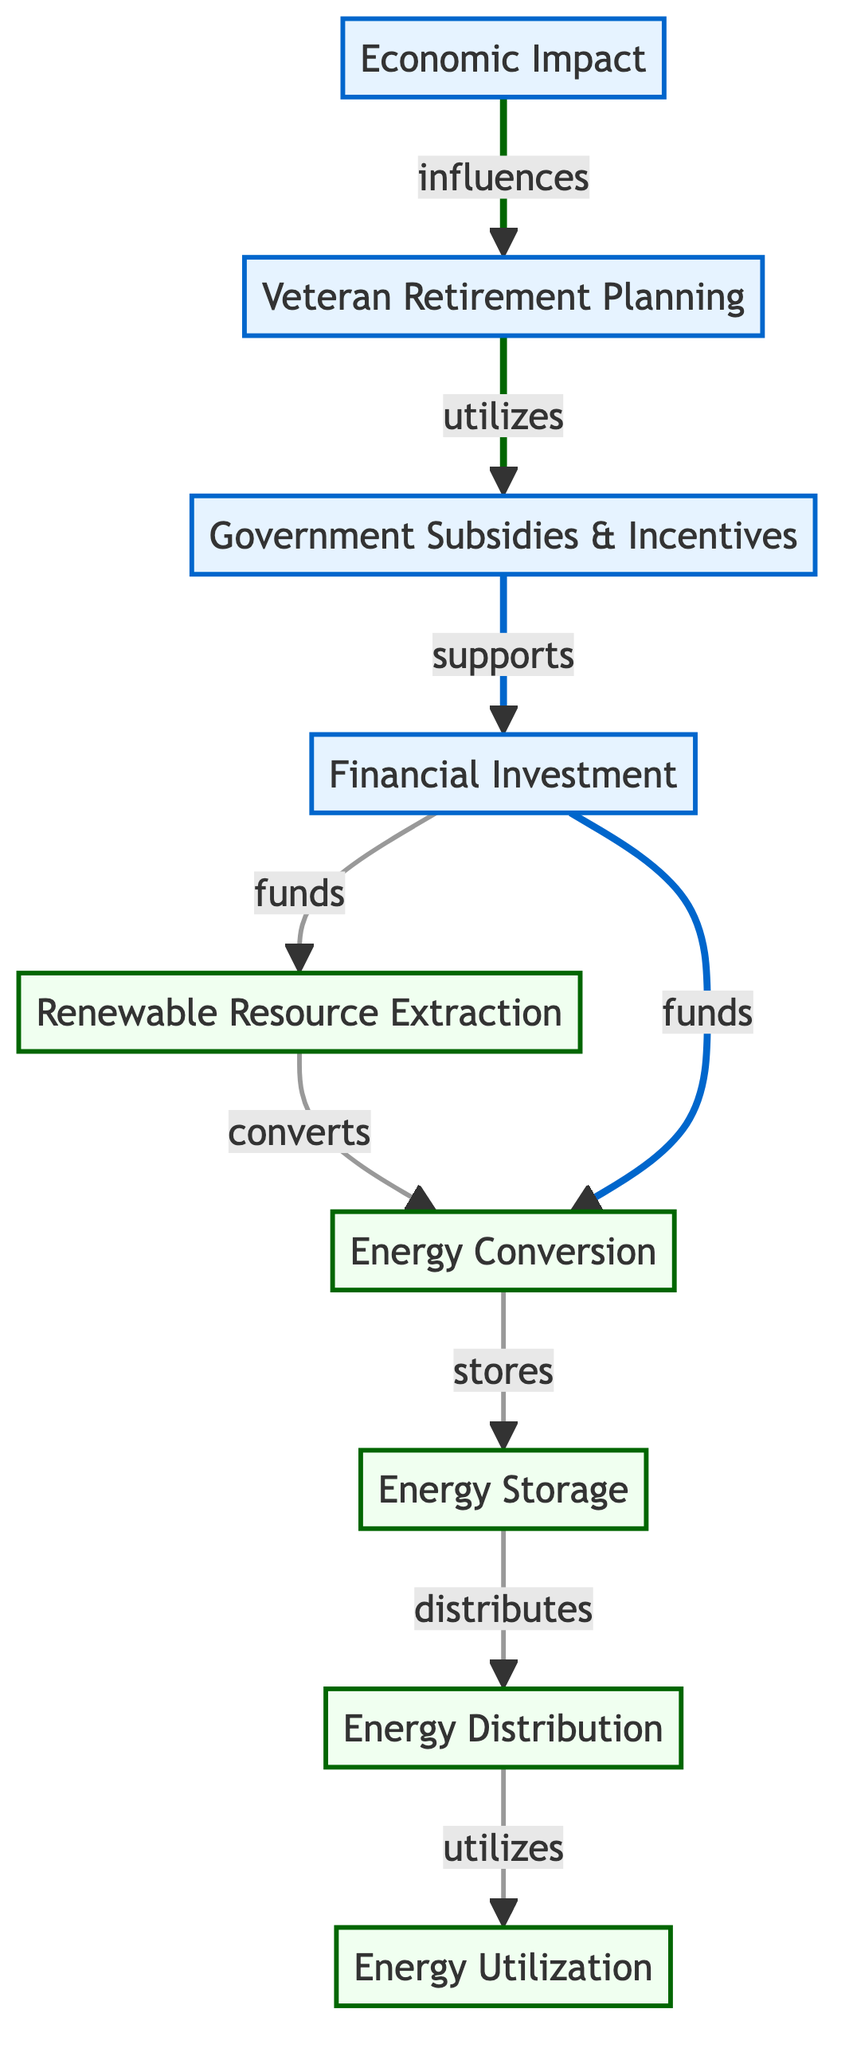What is the first step in the renewable energy lifecycle? The diagram indicates that the first step is "Renewable Resource Extraction." This is the initial node from which the entire process flows.
Answer: Renewable Resource Extraction Which nodes are classified as energy-related? The nodes classified as energy-related are "Renewable Resource Extraction," "Energy Conversion," "Energy Storage," "Energy Distribution," and "Energy Utilization." These are marked under the class 'energy' in the diagram.
Answer: Five nodes What financial element funds the energy lifecycle? The diagram shows that "Financial Investment" is the element that funds various stages of the energy lifecycle, including both extraction and conversion processes.
Answer: Financial Investment How do government subsidies influence financial investment? According to the diagram, "Government Subsidies & Incentives" support "Financial Investment," indicating that these subsidies provide necessary funds for investments in renewable energy.
Answer: Support What is utilized in the veteran retirement planning process? The diagram illustrates that "Government Subsidies & Incentives" are utilized within the "Veteran Retirement Planning," suggesting that veterans can benefit from these incentives in their financial planning.
Answer: Government Subsidies & Incentives How many interactions lead from financial investment to energy extraction? The diagram shows one direct interaction where "Financial Investment" funds "Renewable Resource Extraction." Therefore, there is only one interaction in this case.
Answer: One interaction What is the relationship between economic impact and veteran retirement planning? The diagram states that "Economic Impact" influences "Veteran Retirement Planning," which indicates that economic conditions can affect the financial strategies of veterans.
Answer: Influences What is the final stage of the energy lifecycle shown in the diagram? The last node in the flow of the diagram is "Energy Utilization," which represents the final application of renewable energy.
Answer: Energy Utilization How many total nodes are present in the diagram? By counting each distinct node in the diagram, we find there are eight nodes: five related to energy and three related to financial aspects.
Answer: Eight nodes 